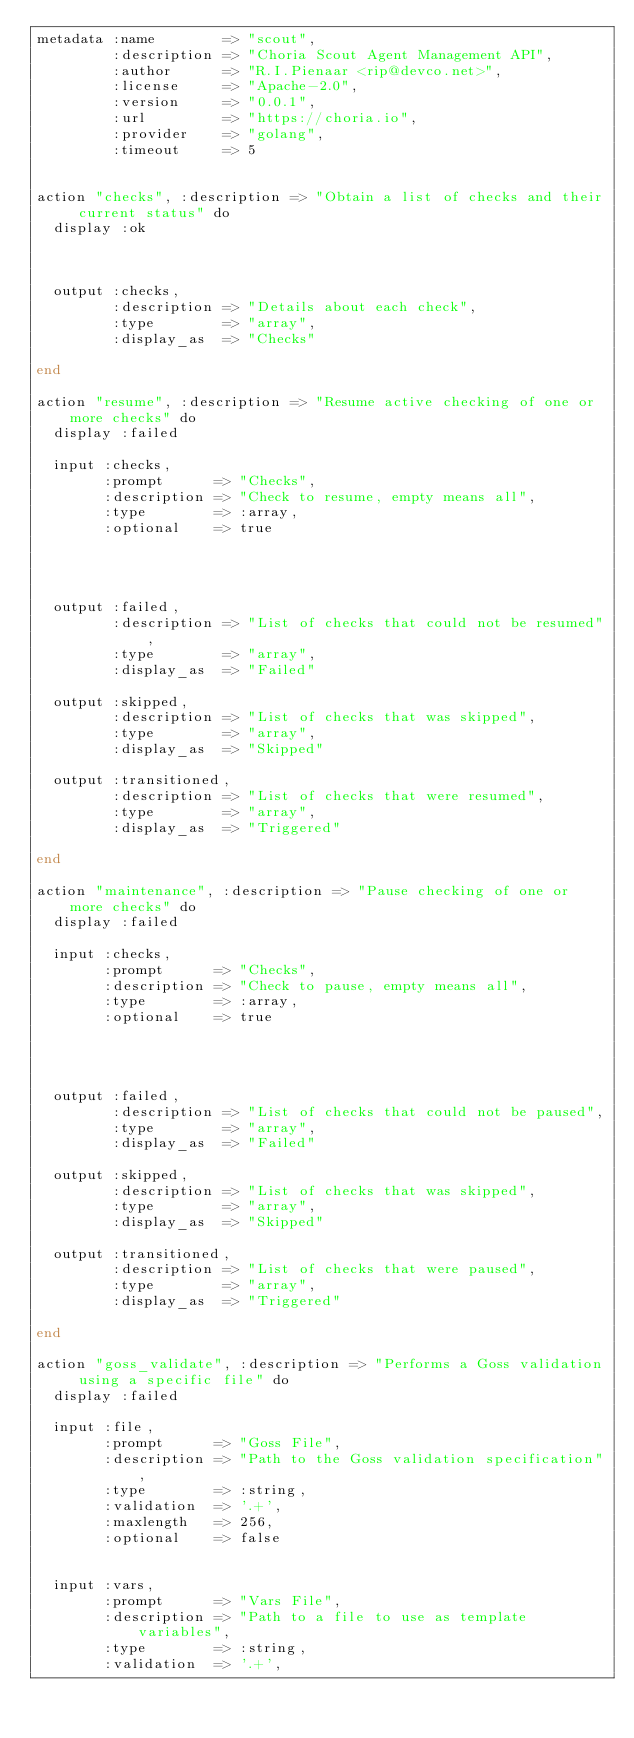Convert code to text. <code><loc_0><loc_0><loc_500><loc_500><_SQL_>metadata :name        => "scout",
         :description => "Choria Scout Agent Management API",
         :author      => "R.I.Pienaar <rip@devco.net>",
         :license     => "Apache-2.0",
         :version     => "0.0.1",
         :url         => "https://choria.io",
         :provider    => "golang",
         :timeout     => 5


action "checks", :description => "Obtain a list of checks and their current status" do
  display :ok



  output :checks,
         :description => "Details about each check",
         :type        => "array",
         :display_as  => "Checks"

end

action "resume", :description => "Resume active checking of one or more checks" do
  display :failed

  input :checks,
        :prompt      => "Checks",
        :description => "Check to resume, empty means all",
        :type        => :array,
        :optional    => true




  output :failed,
         :description => "List of checks that could not be resumed",
         :type        => "array",
         :display_as  => "Failed"

  output :skipped,
         :description => "List of checks that was skipped",
         :type        => "array",
         :display_as  => "Skipped"

  output :transitioned,
         :description => "List of checks that were resumed",
         :type        => "array",
         :display_as  => "Triggered"

end

action "maintenance", :description => "Pause checking of one or more checks" do
  display :failed

  input :checks,
        :prompt      => "Checks",
        :description => "Check to pause, empty means all",
        :type        => :array,
        :optional    => true




  output :failed,
         :description => "List of checks that could not be paused",
         :type        => "array",
         :display_as  => "Failed"

  output :skipped,
         :description => "List of checks that was skipped",
         :type        => "array",
         :display_as  => "Skipped"

  output :transitioned,
         :description => "List of checks that were paused",
         :type        => "array",
         :display_as  => "Triggered"

end

action "goss_validate", :description => "Performs a Goss validation using a specific file" do
  display :failed

  input :file,
        :prompt      => "Goss File",
        :description => "Path to the Goss validation specification",
        :type        => :string,
        :validation  => '.+',
        :maxlength   => 256,
        :optional    => false


  input :vars,
        :prompt      => "Vars File",
        :description => "Path to a file to use as template variables",
        :type        => :string,
        :validation  => '.+',</code> 